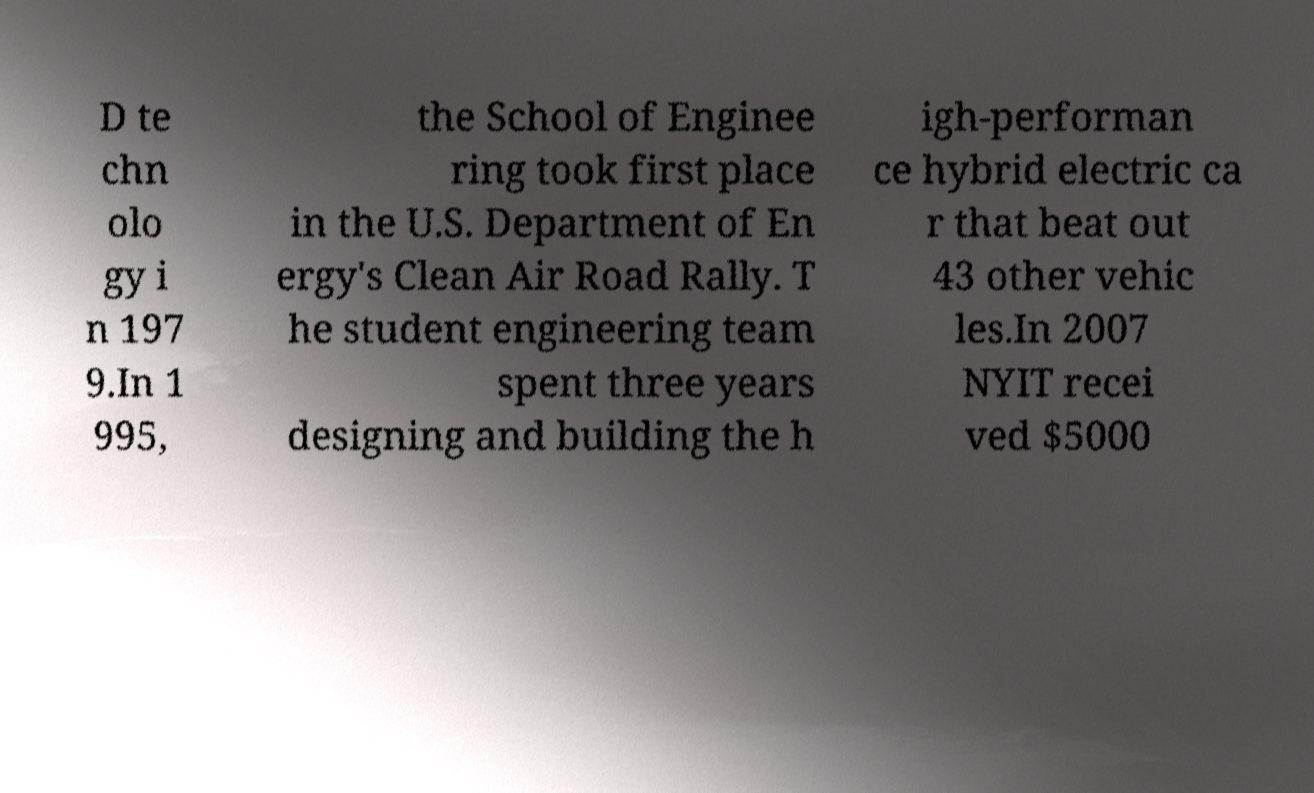What messages or text are displayed in this image? I need them in a readable, typed format. D te chn olo gy i n 197 9.In 1 995, the School of Enginee ring took first place in the U.S. Department of En ergy's Clean Air Road Rally. T he student engineering team spent three years designing and building the h igh-performan ce hybrid electric ca r that beat out 43 other vehic les.In 2007 NYIT recei ved $5000 